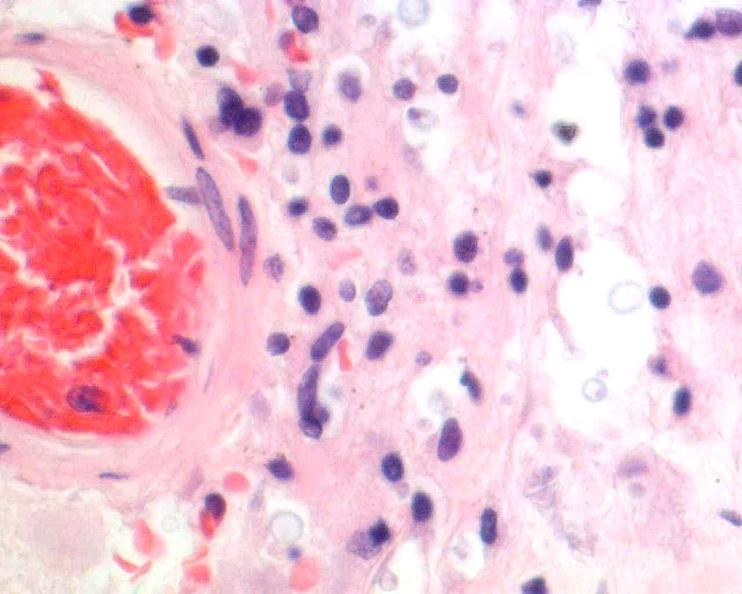what is present?
Answer the question using a single word or phrase. Nervous 